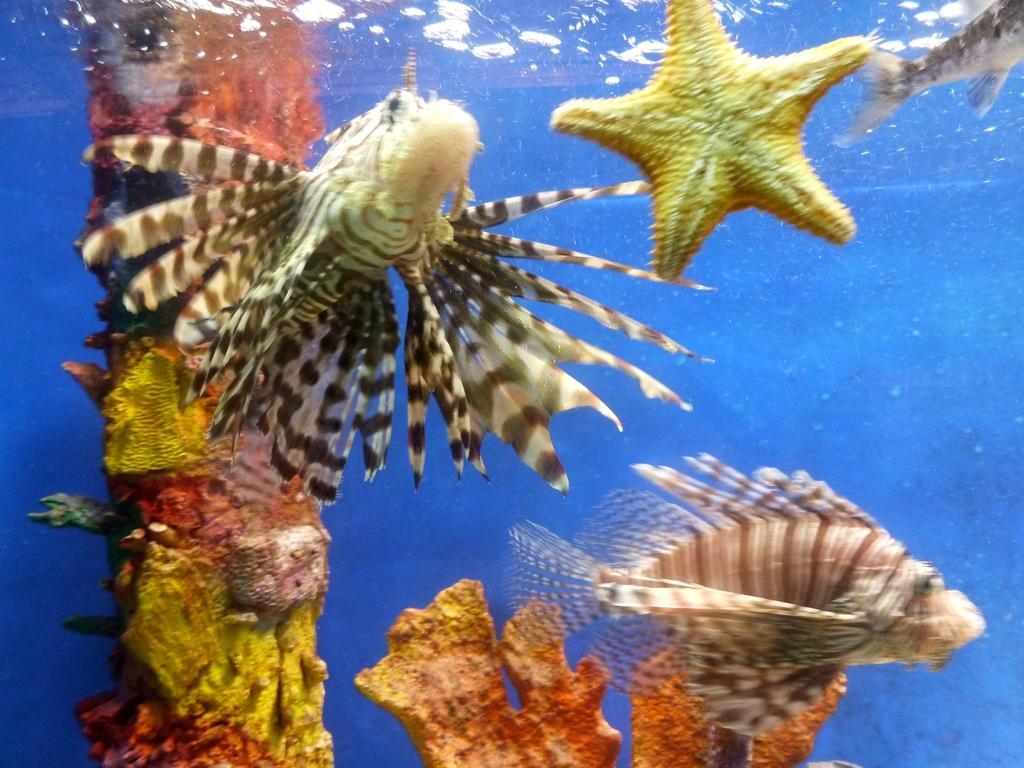In one or two sentences, can you explain what this image depicts? In this picture we can see starfish and a few fishes in the water. There are some colorful objects at the back. We can see a blue color background. 